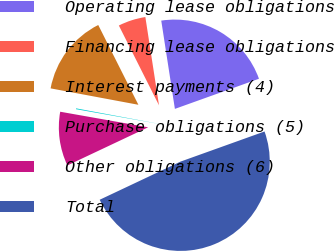Convert chart to OTSL. <chart><loc_0><loc_0><loc_500><loc_500><pie_chart><fcel>Operating lease obligations<fcel>Financing lease obligations<fcel>Interest payments (4)<fcel>Purchase obligations (5)<fcel>Other obligations (6)<fcel>Total<nl><fcel>21.96%<fcel>4.98%<fcel>14.64%<fcel>0.15%<fcel>9.81%<fcel>48.46%<nl></chart> 